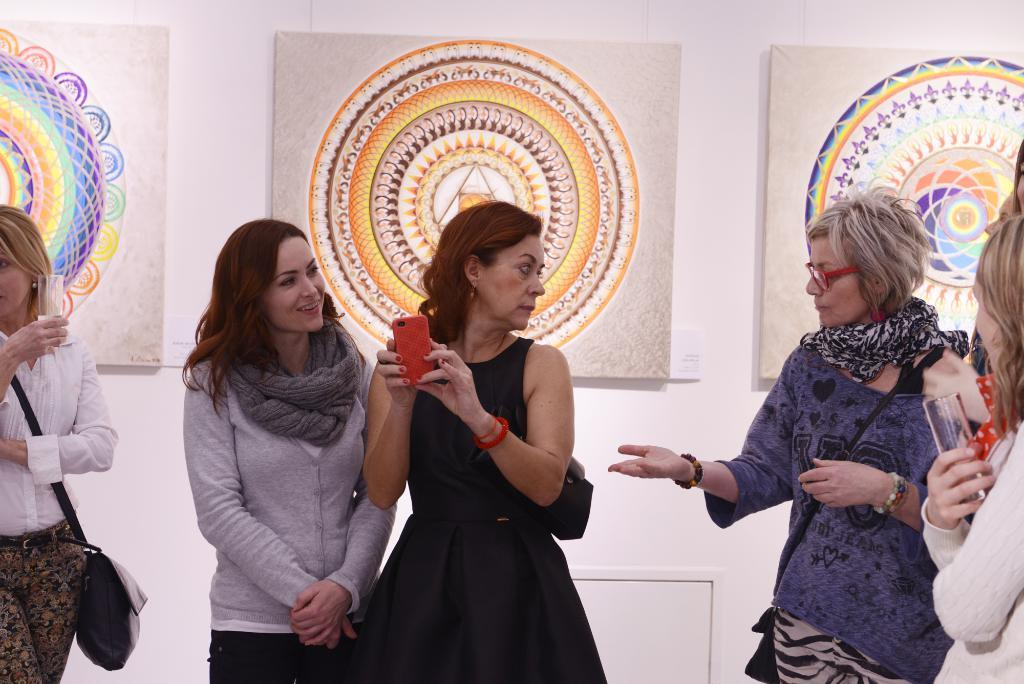What is the main subject of the image? The main subject of the image is women. Can you describe the appearance of the women in the image? The women are wearing different color dresses and are standing. What is the emotional expression of one of the women? One of the women is smiling. What can be seen in the background of the image? There are paintings in the background of different subjects in the background of the image. How are the paintings positioned in the image? The paintings are attached to a white wall. What type of crown can be seen on the head of the woman in the image? There is no crown present on the head of any woman in the image. 